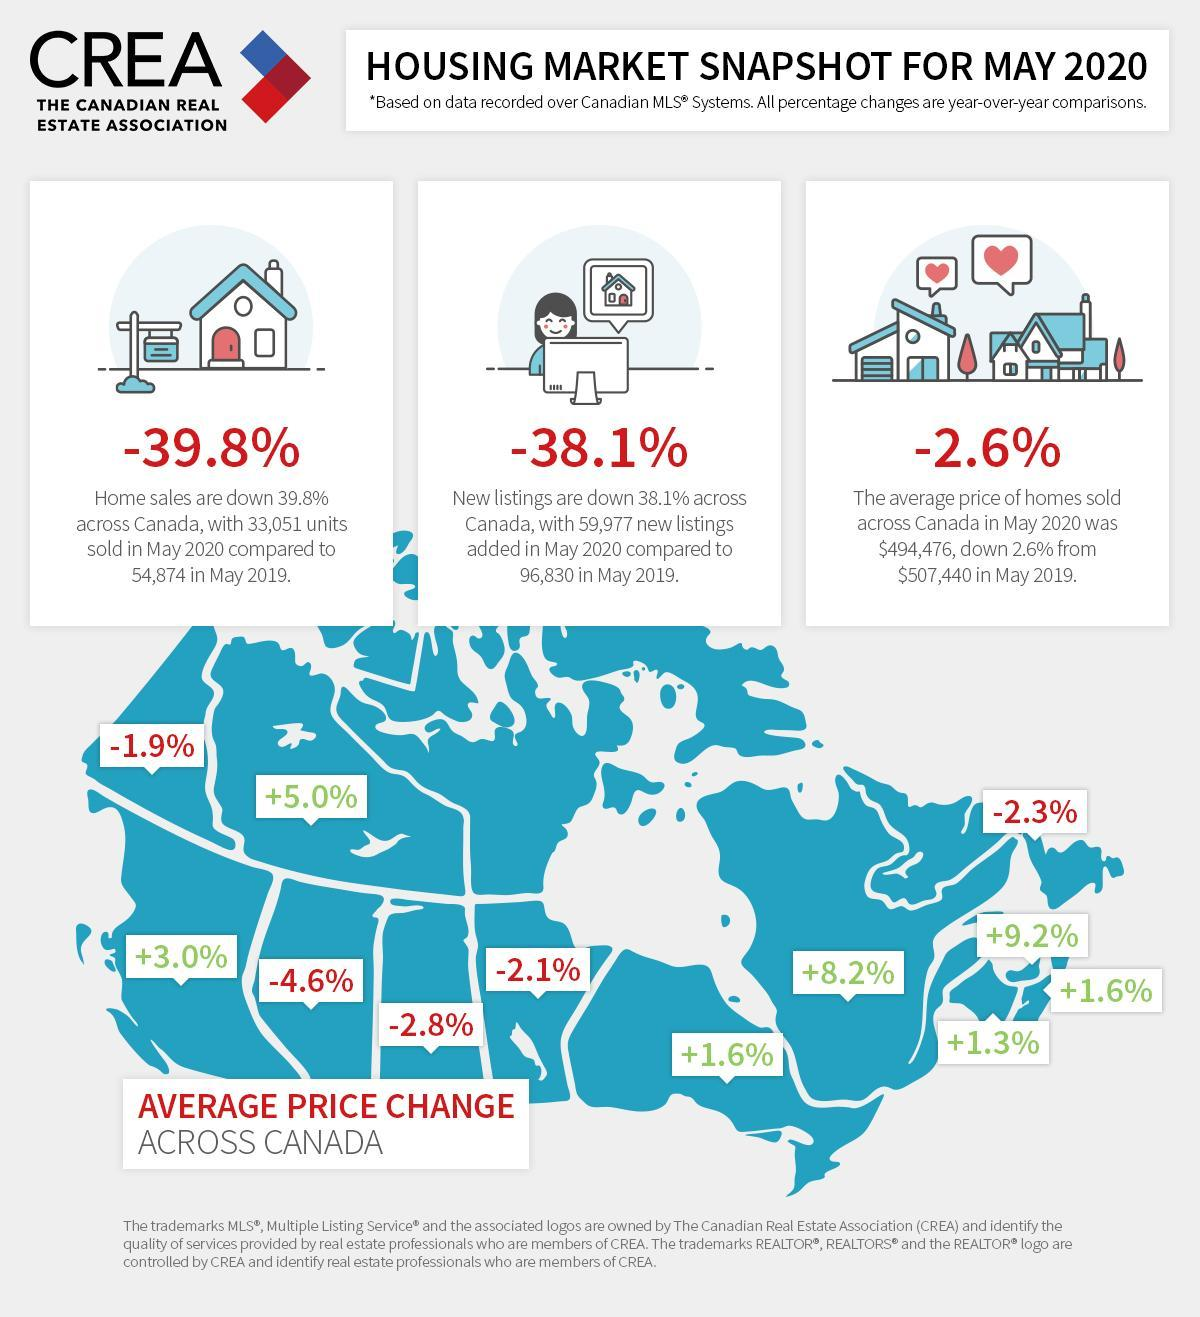How many more homes was sold  in 2019 when compared to 2020?
Answer the question with a short phrase. 21823 What is the highest decrease in average price change? -4.6% What is the highest increase in average price change observed? +9.2% How many 'houses' are shown in the images? 4 Which has shown a greater decline - home sales or new listings? Home sales By how much is the average price of homes sold across Canada in May 2020 lesser than in May 2019? 12964 How many regions show a decrease in the average price change? 5 How much lesser is the new listings in 2020 when compared to 2019? 36853 How many regions show an increase in the average price change across Canada? 7 What is the lowest increase in average price change observed? +1.3% 